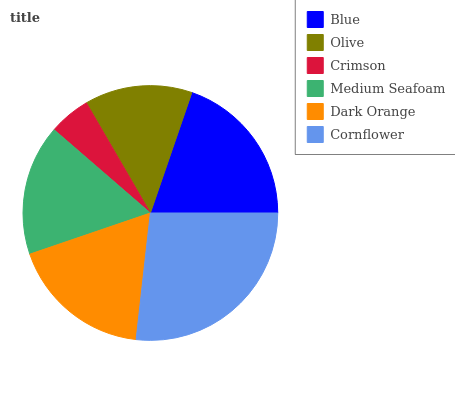Is Crimson the minimum?
Answer yes or no. Yes. Is Cornflower the maximum?
Answer yes or no. Yes. Is Olive the minimum?
Answer yes or no. No. Is Olive the maximum?
Answer yes or no. No. Is Blue greater than Olive?
Answer yes or no. Yes. Is Olive less than Blue?
Answer yes or no. Yes. Is Olive greater than Blue?
Answer yes or no. No. Is Blue less than Olive?
Answer yes or no. No. Is Dark Orange the high median?
Answer yes or no. Yes. Is Medium Seafoam the low median?
Answer yes or no. Yes. Is Medium Seafoam the high median?
Answer yes or no. No. Is Crimson the low median?
Answer yes or no. No. 